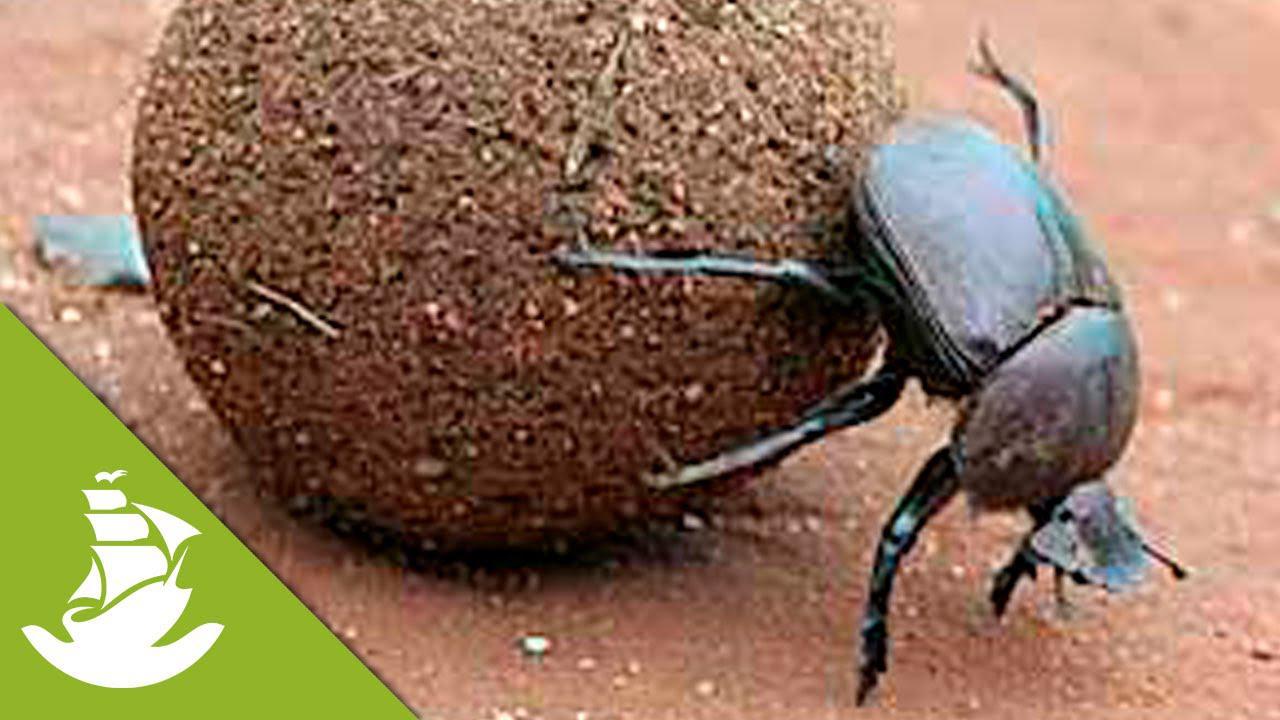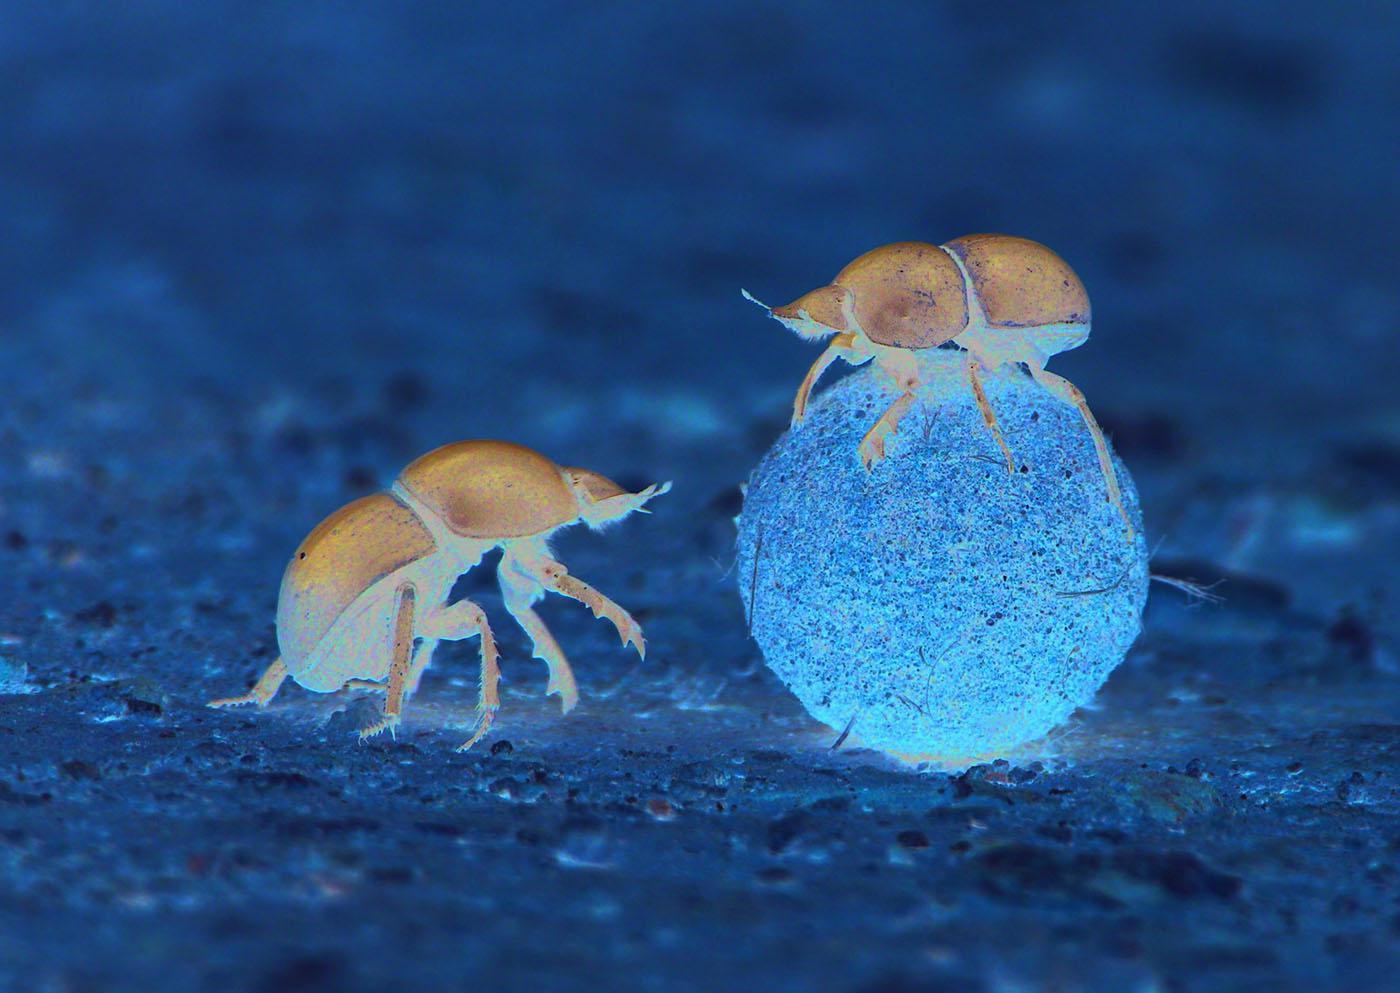The first image is the image on the left, the second image is the image on the right. Examine the images to the left and right. Is the description "Each image features a beetle in contact with a dung ball." accurate? Answer yes or no. Yes. The first image is the image on the left, the second image is the image on the right. Given the left and right images, does the statement "Only one beetle is on a ball of dirt." hold true? Answer yes or no. No. 